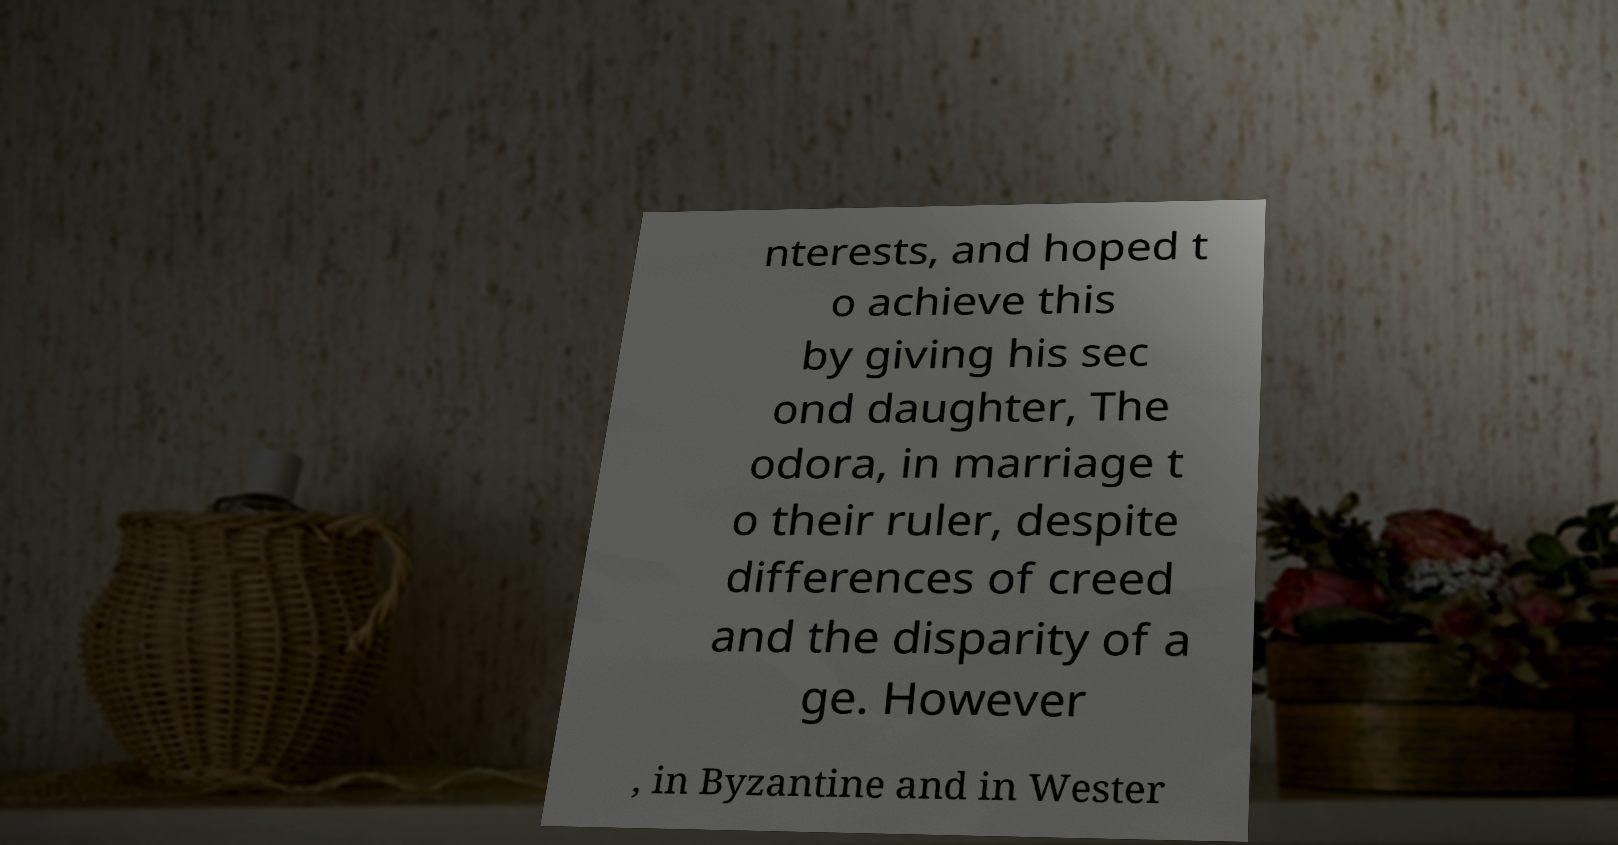Can you read and provide the text displayed in the image?This photo seems to have some interesting text. Can you extract and type it out for me? nterests, and hoped t o achieve this by giving his sec ond daughter, The odora, in marriage t o their ruler, despite differences of creed and the disparity of a ge. However , in Byzantine and in Wester 